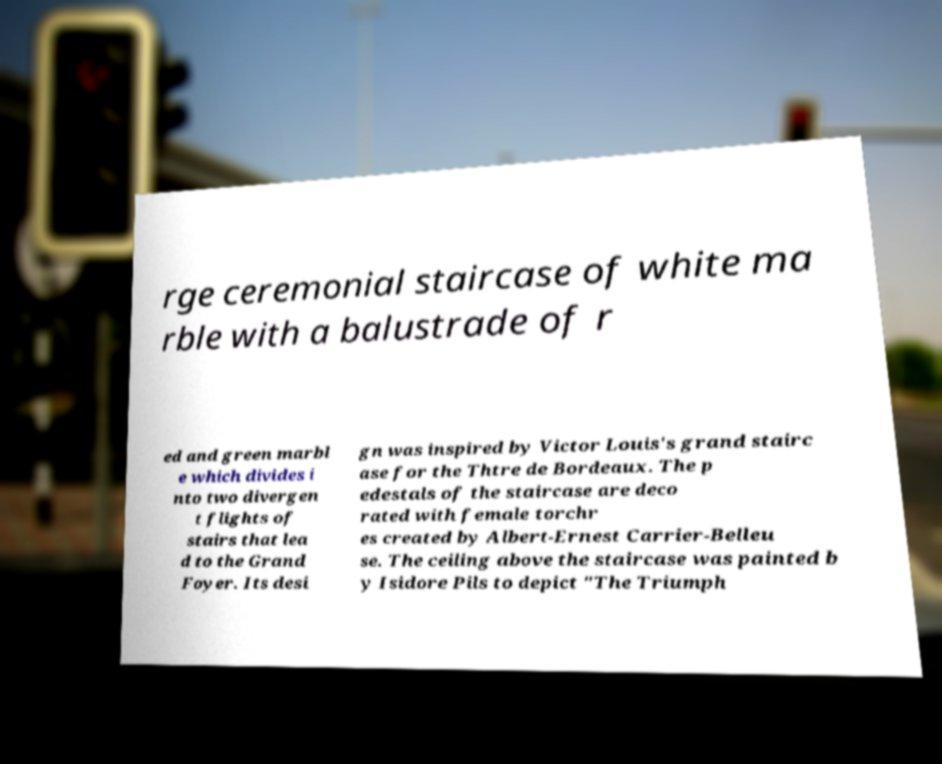Please identify and transcribe the text found in this image. rge ceremonial staircase of white ma rble with a balustrade of r ed and green marbl e which divides i nto two divergen t flights of stairs that lea d to the Grand Foyer. Its desi gn was inspired by Victor Louis's grand stairc ase for the Thtre de Bordeaux. The p edestals of the staircase are deco rated with female torchr es created by Albert-Ernest Carrier-Belleu se. The ceiling above the staircase was painted b y Isidore Pils to depict "The Triumph 